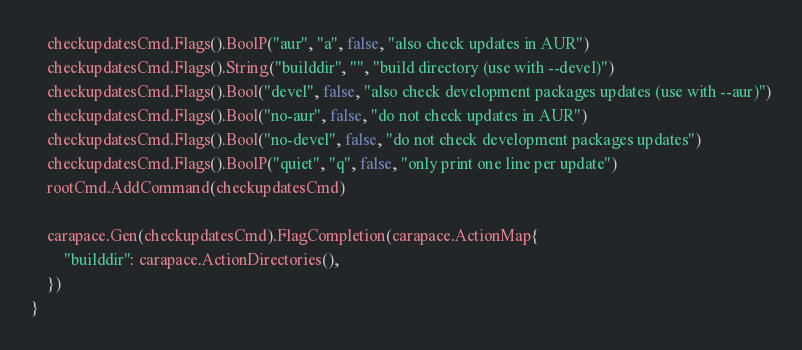<code> <loc_0><loc_0><loc_500><loc_500><_Go_>
	checkupdatesCmd.Flags().BoolP("aur", "a", false, "also check updates in AUR")
	checkupdatesCmd.Flags().String("builddir", "", "build directory (use with --devel)")
	checkupdatesCmd.Flags().Bool("devel", false, "also check development packages updates (use with --aur)")
	checkupdatesCmd.Flags().Bool("no-aur", false, "do not check updates in AUR")
	checkupdatesCmd.Flags().Bool("no-devel", false, "do not check development packages updates")
	checkupdatesCmd.Flags().BoolP("quiet", "q", false, "only print one line per update")
	rootCmd.AddCommand(checkupdatesCmd)

	carapace.Gen(checkupdatesCmd).FlagCompletion(carapace.ActionMap{
		"builddir": carapace.ActionDirectories(),
	})
}
</code> 